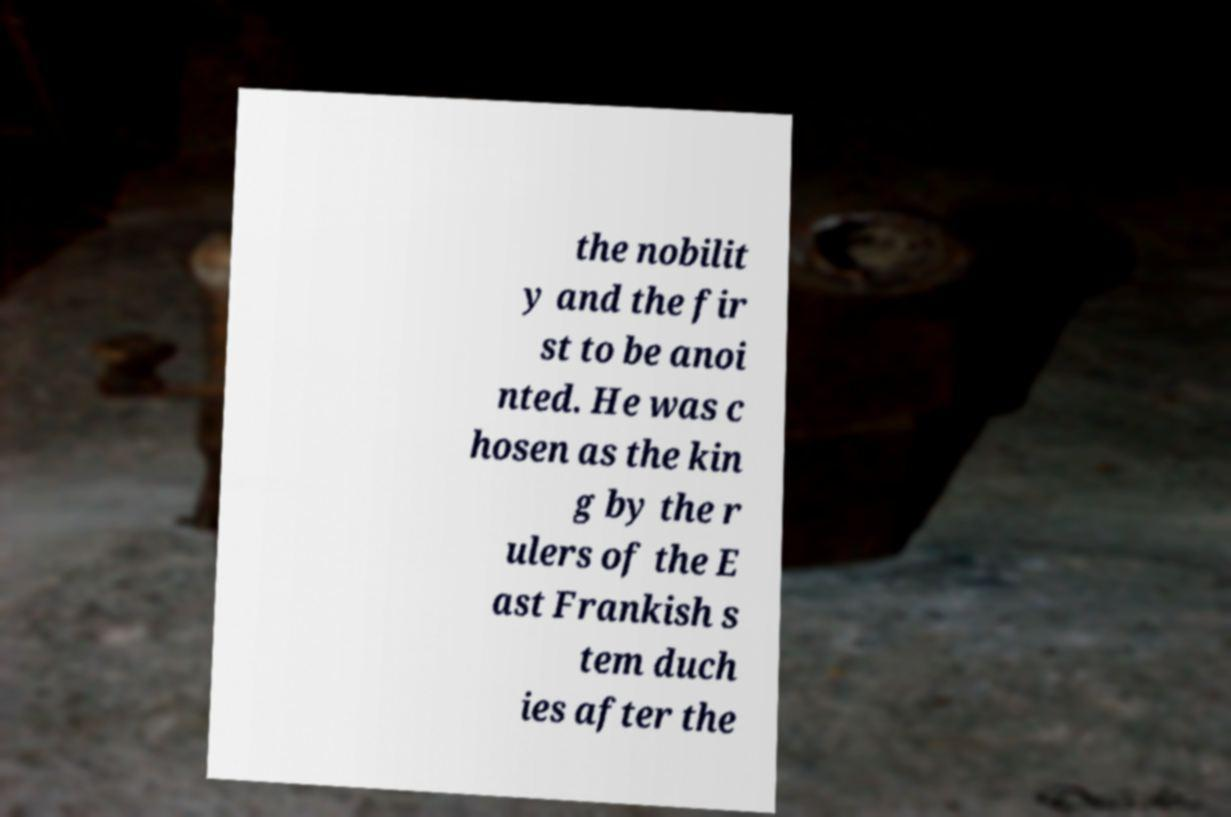Could you extract and type out the text from this image? the nobilit y and the fir st to be anoi nted. He was c hosen as the kin g by the r ulers of the E ast Frankish s tem duch ies after the 